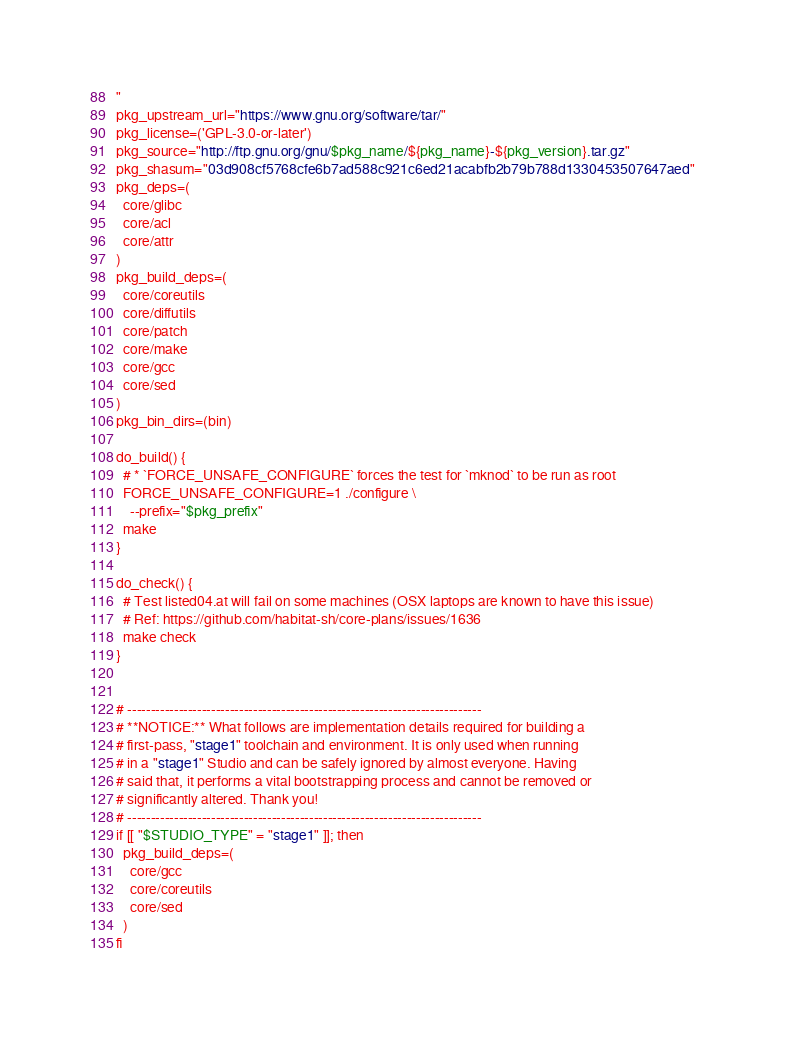Convert code to text. <code><loc_0><loc_0><loc_500><loc_500><_Bash_>"
pkg_upstream_url="https://www.gnu.org/software/tar/"
pkg_license=('GPL-3.0-or-later')
pkg_source="http://ftp.gnu.org/gnu/$pkg_name/${pkg_name}-${pkg_version}.tar.gz"
pkg_shasum="03d908cf5768cfe6b7ad588c921c6ed21acabfb2b79b788d1330453507647aed"
pkg_deps=(
  core/glibc
  core/acl
  core/attr
)
pkg_build_deps=(
  core/coreutils
  core/diffutils
  core/patch
  core/make
  core/gcc
  core/sed
)
pkg_bin_dirs=(bin)

do_build() {
  # * `FORCE_UNSAFE_CONFIGURE` forces the test for `mknod` to be run as root
  FORCE_UNSAFE_CONFIGURE=1 ./configure \
    --prefix="$pkg_prefix"
  make
}

do_check() {
  # Test listed04.at will fail on some machines (OSX laptops are known to have this issue)
  # Ref: https://github.com/habitat-sh/core-plans/issues/1636
  make check
}


# ----------------------------------------------------------------------------
# **NOTICE:** What follows are implementation details required for building a
# first-pass, "stage1" toolchain and environment. It is only used when running
# in a "stage1" Studio and can be safely ignored by almost everyone. Having
# said that, it performs a vital bootstrapping process and cannot be removed or
# significantly altered. Thank you!
# ----------------------------------------------------------------------------
if [[ "$STUDIO_TYPE" = "stage1" ]]; then
  pkg_build_deps=(
    core/gcc
    core/coreutils
    core/sed
  )
fi
</code> 